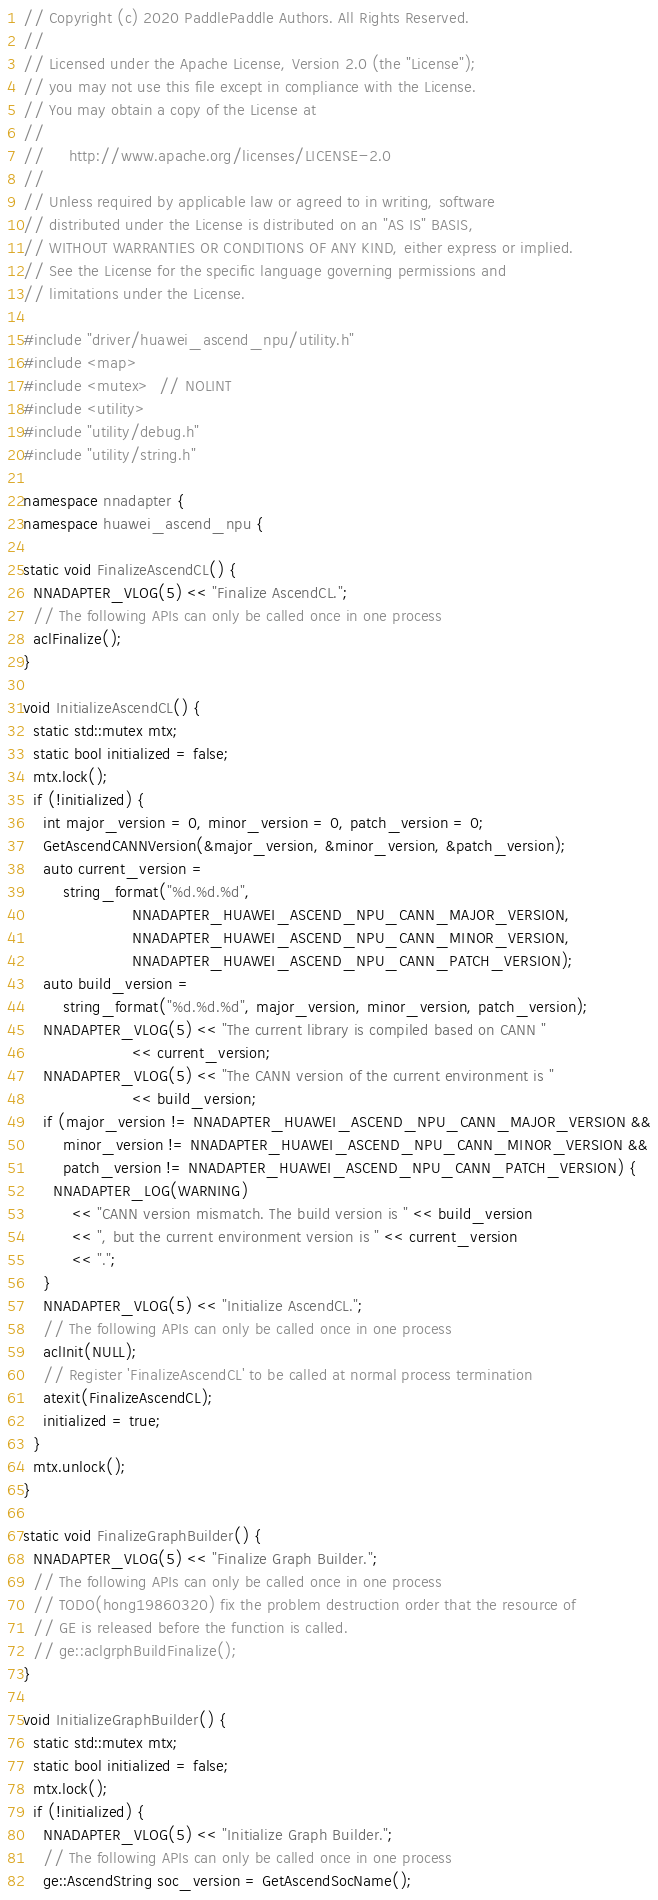<code> <loc_0><loc_0><loc_500><loc_500><_C++_>// Copyright (c) 2020 PaddlePaddle Authors. All Rights Reserved.
//
// Licensed under the Apache License, Version 2.0 (the "License");
// you may not use this file except in compliance with the License.
// You may obtain a copy of the License at
//
//     http://www.apache.org/licenses/LICENSE-2.0
//
// Unless required by applicable law or agreed to in writing, software
// distributed under the License is distributed on an "AS IS" BASIS,
// WITHOUT WARRANTIES OR CONDITIONS OF ANY KIND, either express or implied.
// See the License for the specific language governing permissions and
// limitations under the License.

#include "driver/huawei_ascend_npu/utility.h"
#include <map>
#include <mutex>  // NOLINT
#include <utility>
#include "utility/debug.h"
#include "utility/string.h"

namespace nnadapter {
namespace huawei_ascend_npu {

static void FinalizeAscendCL() {
  NNADAPTER_VLOG(5) << "Finalize AscendCL.";
  // The following APIs can only be called once in one process
  aclFinalize();
}

void InitializeAscendCL() {
  static std::mutex mtx;
  static bool initialized = false;
  mtx.lock();
  if (!initialized) {
    int major_version = 0, minor_version = 0, patch_version = 0;
    GetAscendCANNVersion(&major_version, &minor_version, &patch_version);
    auto current_version =
        string_format("%d.%d.%d",
                      NNADAPTER_HUAWEI_ASCEND_NPU_CANN_MAJOR_VERSION,
                      NNADAPTER_HUAWEI_ASCEND_NPU_CANN_MINOR_VERSION,
                      NNADAPTER_HUAWEI_ASCEND_NPU_CANN_PATCH_VERSION);
    auto build_version =
        string_format("%d.%d.%d", major_version, minor_version, patch_version);
    NNADAPTER_VLOG(5) << "The current library is compiled based on CANN "
                      << current_version;
    NNADAPTER_VLOG(5) << "The CANN version of the current environment is "
                      << build_version;
    if (major_version != NNADAPTER_HUAWEI_ASCEND_NPU_CANN_MAJOR_VERSION &&
        minor_version != NNADAPTER_HUAWEI_ASCEND_NPU_CANN_MINOR_VERSION &&
        patch_version != NNADAPTER_HUAWEI_ASCEND_NPU_CANN_PATCH_VERSION) {
      NNADAPTER_LOG(WARNING)
          << "CANN version mismatch. The build version is " << build_version
          << ", but the current environment version is " << current_version
          << ".";
    }
    NNADAPTER_VLOG(5) << "Initialize AscendCL.";
    // The following APIs can only be called once in one process
    aclInit(NULL);
    // Register 'FinalizeAscendCL' to be called at normal process termination
    atexit(FinalizeAscendCL);
    initialized = true;
  }
  mtx.unlock();
}

static void FinalizeGraphBuilder() {
  NNADAPTER_VLOG(5) << "Finalize Graph Builder.";
  // The following APIs can only be called once in one process
  // TODO(hong19860320) fix the problem destruction order that the resource of
  // GE is released before the function is called.
  // ge::aclgrphBuildFinalize();
}

void InitializeGraphBuilder() {
  static std::mutex mtx;
  static bool initialized = false;
  mtx.lock();
  if (!initialized) {
    NNADAPTER_VLOG(5) << "Initialize Graph Builder.";
    // The following APIs can only be called once in one process
    ge::AscendString soc_version = GetAscendSocName();</code> 